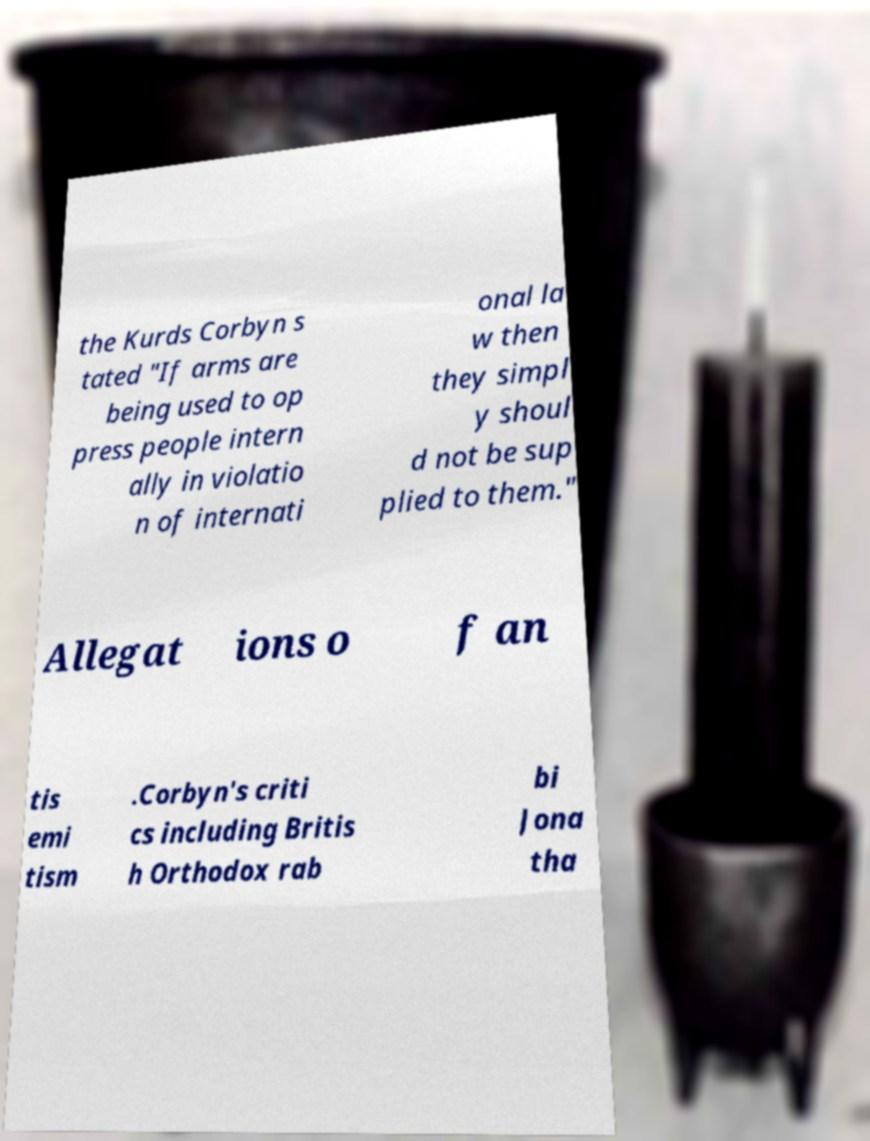Could you assist in decoding the text presented in this image and type it out clearly? the Kurds Corbyn s tated "If arms are being used to op press people intern ally in violatio n of internati onal la w then they simpl y shoul d not be sup plied to them." Allegat ions o f an tis emi tism .Corbyn's criti cs including Britis h Orthodox rab bi Jona tha 